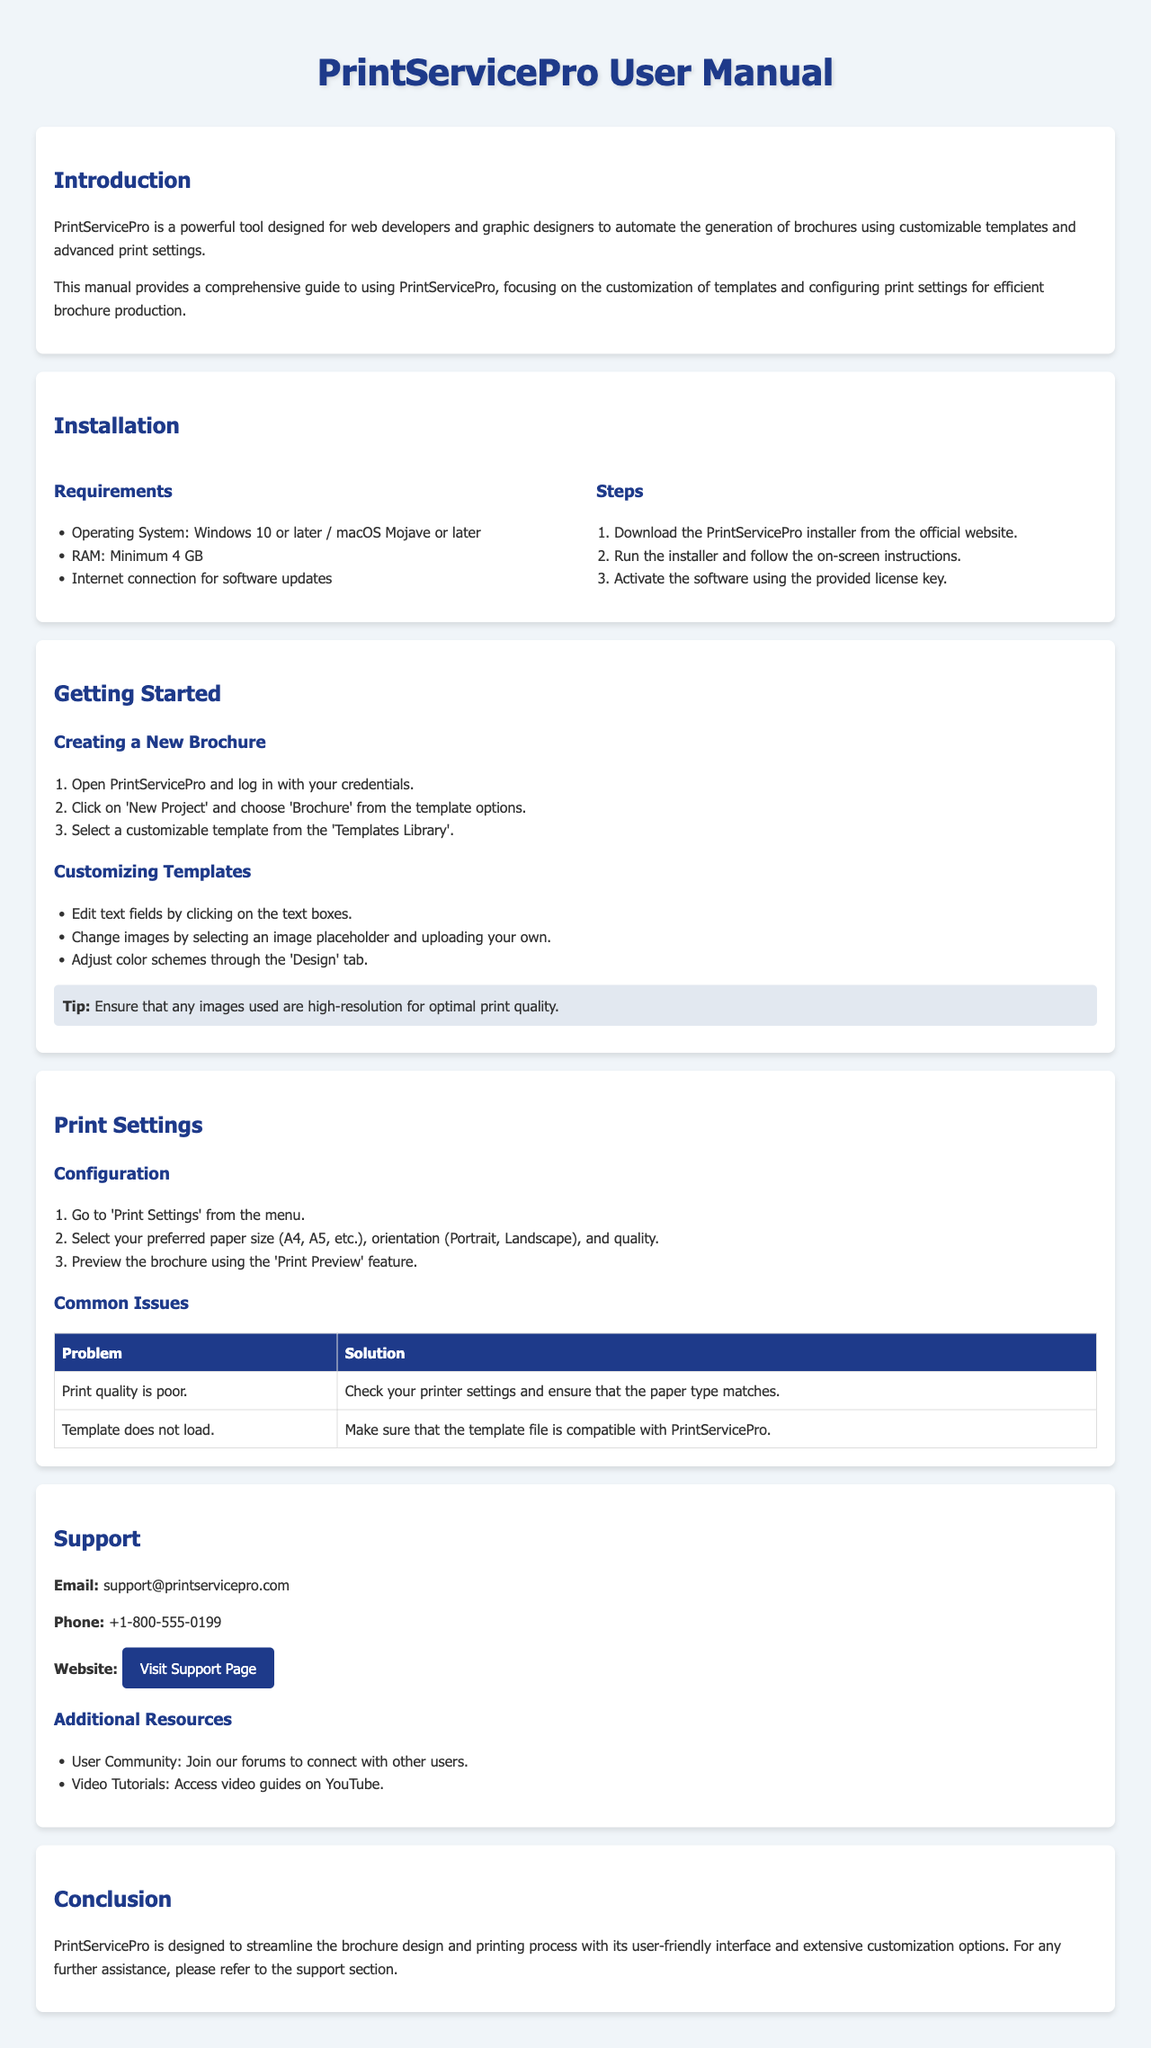What is the name of the tool? The name of the tool as stated in the document is PrintServicePro.
Answer: PrintServicePro What are the minimum RAM requirements? The RAM requirement is specified under the installation section.
Answer: Minimum 4 GB What should you do if the print quality is poor? The solution to this problem is listed in the common issues section.
Answer: Check your printer settings and ensure that the paper type matches How can you access video tutorials? The resource for video tutorials is mentioned in the support section.
Answer: Access video guides on YouTube What is the email address for support? The support email is provided in the support section.
Answer: support@printservicepro.com How do you create a new brochure? The steps for creating a new brochure are outlined in the Getting Started section.
Answer: Click on 'New Project' and choose 'Brochure' What should be ensured for optimal print quality? This tip is mentioned in the Getting Started section under Customizing Templates.
Answer: Ensure that any images used are high-resolution Which operating systems are supported? The supported operating systems are listed in the requirements of the installation section.
Answer: Windows 10 or later / macOS Mojave or later What feature allows you to preview the brochure? This feature is mentioned in the Print Settings section.
Answer: Print Preview 